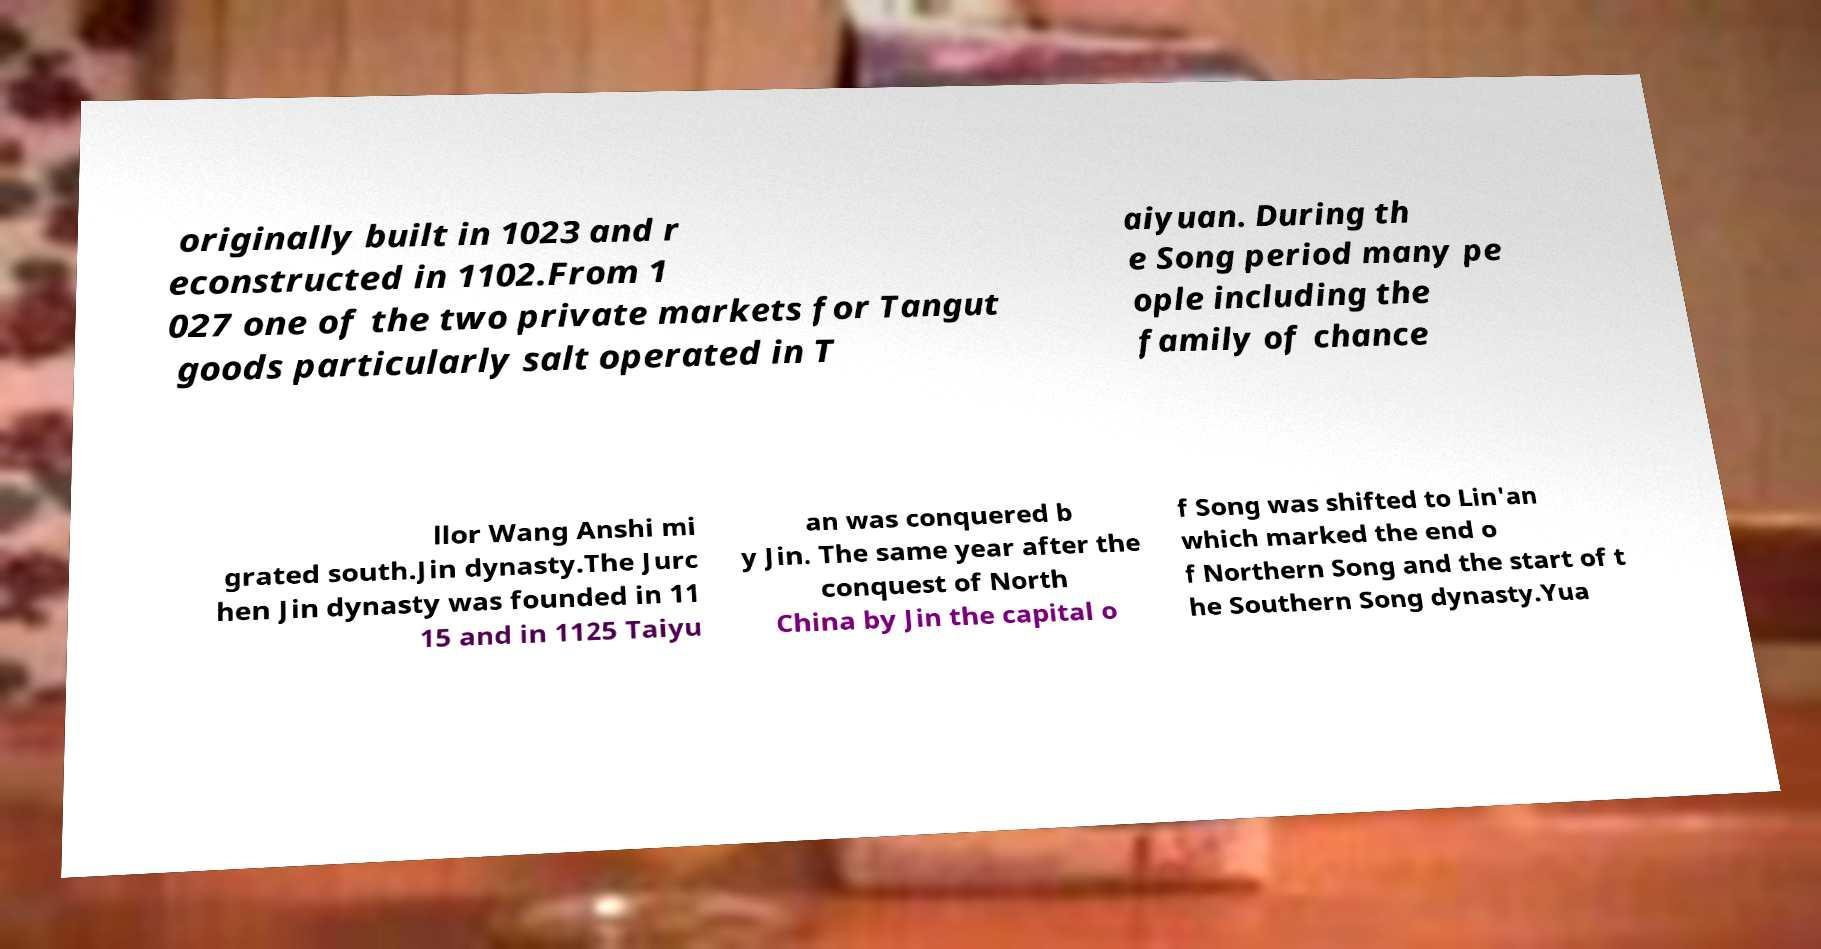There's text embedded in this image that I need extracted. Can you transcribe it verbatim? originally built in 1023 and r econstructed in 1102.From 1 027 one of the two private markets for Tangut goods particularly salt operated in T aiyuan. During th e Song period many pe ople including the family of chance llor Wang Anshi mi grated south.Jin dynasty.The Jurc hen Jin dynasty was founded in 11 15 and in 1125 Taiyu an was conquered b y Jin. The same year after the conquest of North China by Jin the capital o f Song was shifted to Lin'an which marked the end o f Northern Song and the start of t he Southern Song dynasty.Yua 